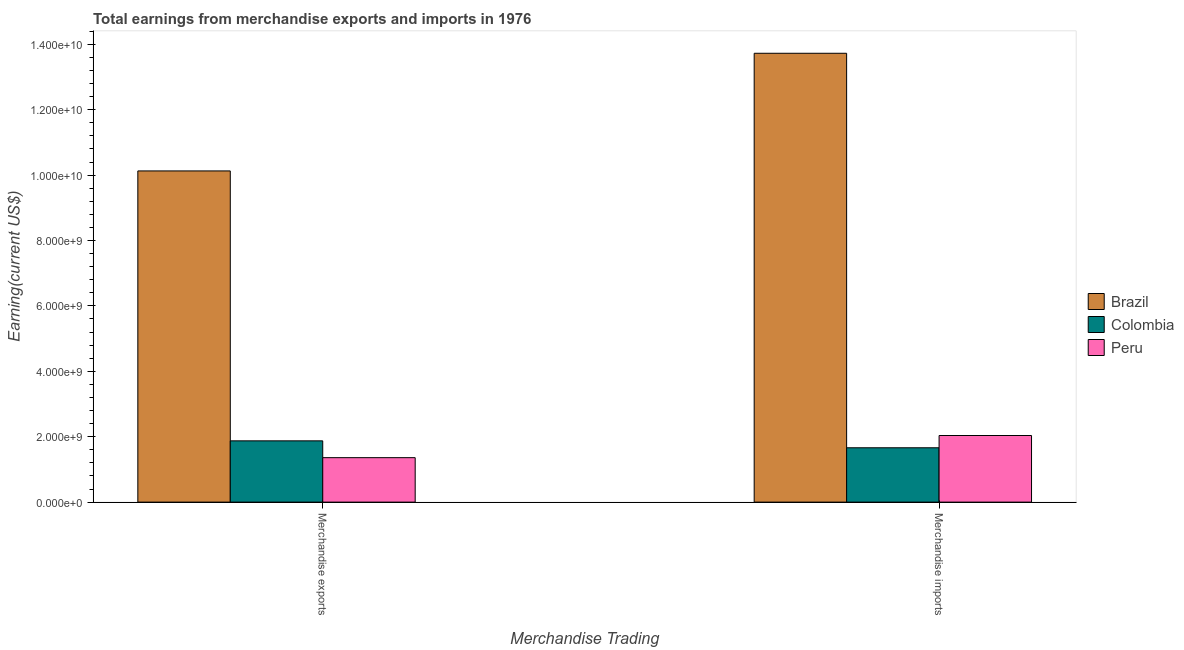How many different coloured bars are there?
Give a very brief answer. 3. How many groups of bars are there?
Keep it short and to the point. 2. Are the number of bars per tick equal to the number of legend labels?
Offer a terse response. Yes. How many bars are there on the 1st tick from the right?
Keep it short and to the point. 3. What is the label of the 2nd group of bars from the left?
Your answer should be compact. Merchandise imports. What is the earnings from merchandise imports in Peru?
Give a very brief answer. 2.04e+09. Across all countries, what is the maximum earnings from merchandise exports?
Provide a short and direct response. 1.01e+1. Across all countries, what is the minimum earnings from merchandise imports?
Give a very brief answer. 1.66e+09. What is the total earnings from merchandise exports in the graph?
Ensure brevity in your answer.  1.34e+1. What is the difference between the earnings from merchandise imports in Brazil and that in Colombia?
Your answer should be compact. 1.21e+1. What is the difference between the earnings from merchandise imports in Colombia and the earnings from merchandise exports in Brazil?
Make the answer very short. -8.47e+09. What is the average earnings from merchandise exports per country?
Offer a very short reply. 4.45e+09. What is the difference between the earnings from merchandise exports and earnings from merchandise imports in Colombia?
Your answer should be compact. 2.12e+08. In how many countries, is the earnings from merchandise exports greater than 8000000000 US$?
Offer a terse response. 1. What is the ratio of the earnings from merchandise exports in Colombia to that in Peru?
Ensure brevity in your answer.  1.38. In how many countries, is the earnings from merchandise exports greater than the average earnings from merchandise exports taken over all countries?
Keep it short and to the point. 1. What does the 1st bar from the left in Merchandise imports represents?
Offer a very short reply. Brazil. What does the 3rd bar from the right in Merchandise imports represents?
Offer a very short reply. Brazil. Are the values on the major ticks of Y-axis written in scientific E-notation?
Make the answer very short. Yes. Does the graph contain any zero values?
Ensure brevity in your answer.  No. Does the graph contain grids?
Ensure brevity in your answer.  No. What is the title of the graph?
Keep it short and to the point. Total earnings from merchandise exports and imports in 1976. What is the label or title of the X-axis?
Offer a terse response. Merchandise Trading. What is the label or title of the Y-axis?
Give a very brief answer. Earning(current US$). What is the Earning(current US$) in Brazil in Merchandise exports?
Provide a succinct answer. 1.01e+1. What is the Earning(current US$) in Colombia in Merchandise exports?
Your response must be concise. 1.87e+09. What is the Earning(current US$) of Peru in Merchandise exports?
Provide a succinct answer. 1.36e+09. What is the Earning(current US$) of Brazil in Merchandise imports?
Your answer should be very brief. 1.37e+1. What is the Earning(current US$) of Colombia in Merchandise imports?
Make the answer very short. 1.66e+09. What is the Earning(current US$) of Peru in Merchandise imports?
Your answer should be compact. 2.04e+09. Across all Merchandise Trading, what is the maximum Earning(current US$) of Brazil?
Offer a terse response. 1.37e+1. Across all Merchandise Trading, what is the maximum Earning(current US$) of Colombia?
Offer a terse response. 1.87e+09. Across all Merchandise Trading, what is the maximum Earning(current US$) in Peru?
Keep it short and to the point. 2.04e+09. Across all Merchandise Trading, what is the minimum Earning(current US$) of Brazil?
Offer a very short reply. 1.01e+1. Across all Merchandise Trading, what is the minimum Earning(current US$) in Colombia?
Your answer should be very brief. 1.66e+09. Across all Merchandise Trading, what is the minimum Earning(current US$) of Peru?
Your response must be concise. 1.36e+09. What is the total Earning(current US$) of Brazil in the graph?
Give a very brief answer. 2.39e+1. What is the total Earning(current US$) of Colombia in the graph?
Make the answer very short. 3.54e+09. What is the total Earning(current US$) in Peru in the graph?
Offer a terse response. 3.40e+09. What is the difference between the Earning(current US$) in Brazil in Merchandise exports and that in Merchandise imports?
Ensure brevity in your answer.  -3.60e+09. What is the difference between the Earning(current US$) in Colombia in Merchandise exports and that in Merchandise imports?
Offer a terse response. 2.12e+08. What is the difference between the Earning(current US$) of Peru in Merchandise exports and that in Merchandise imports?
Ensure brevity in your answer.  -6.78e+08. What is the difference between the Earning(current US$) in Brazil in Merchandise exports and the Earning(current US$) in Colombia in Merchandise imports?
Keep it short and to the point. 8.47e+09. What is the difference between the Earning(current US$) in Brazil in Merchandise exports and the Earning(current US$) in Peru in Merchandise imports?
Provide a succinct answer. 8.09e+09. What is the difference between the Earning(current US$) of Colombia in Merchandise exports and the Earning(current US$) of Peru in Merchandise imports?
Keep it short and to the point. -1.63e+08. What is the average Earning(current US$) in Brazil per Merchandise Trading?
Provide a succinct answer. 1.19e+1. What is the average Earning(current US$) in Colombia per Merchandise Trading?
Your answer should be compact. 1.77e+09. What is the average Earning(current US$) in Peru per Merchandise Trading?
Provide a short and direct response. 1.70e+09. What is the difference between the Earning(current US$) in Brazil and Earning(current US$) in Colombia in Merchandise exports?
Provide a succinct answer. 8.25e+09. What is the difference between the Earning(current US$) in Brazil and Earning(current US$) in Peru in Merchandise exports?
Your response must be concise. 8.77e+09. What is the difference between the Earning(current US$) in Colombia and Earning(current US$) in Peru in Merchandise exports?
Your response must be concise. 5.14e+08. What is the difference between the Earning(current US$) in Brazil and Earning(current US$) in Colombia in Merchandise imports?
Your answer should be very brief. 1.21e+1. What is the difference between the Earning(current US$) in Brazil and Earning(current US$) in Peru in Merchandise imports?
Give a very brief answer. 1.17e+1. What is the difference between the Earning(current US$) in Colombia and Earning(current US$) in Peru in Merchandise imports?
Make the answer very short. -3.75e+08. What is the ratio of the Earning(current US$) in Brazil in Merchandise exports to that in Merchandise imports?
Make the answer very short. 0.74. What is the ratio of the Earning(current US$) of Colombia in Merchandise exports to that in Merchandise imports?
Your answer should be very brief. 1.13. What is the ratio of the Earning(current US$) of Peru in Merchandise exports to that in Merchandise imports?
Offer a terse response. 0.67. What is the difference between the highest and the second highest Earning(current US$) of Brazil?
Offer a very short reply. 3.60e+09. What is the difference between the highest and the second highest Earning(current US$) in Colombia?
Make the answer very short. 2.12e+08. What is the difference between the highest and the second highest Earning(current US$) of Peru?
Ensure brevity in your answer.  6.78e+08. What is the difference between the highest and the lowest Earning(current US$) in Brazil?
Make the answer very short. 3.60e+09. What is the difference between the highest and the lowest Earning(current US$) in Colombia?
Your response must be concise. 2.12e+08. What is the difference between the highest and the lowest Earning(current US$) in Peru?
Offer a very short reply. 6.78e+08. 